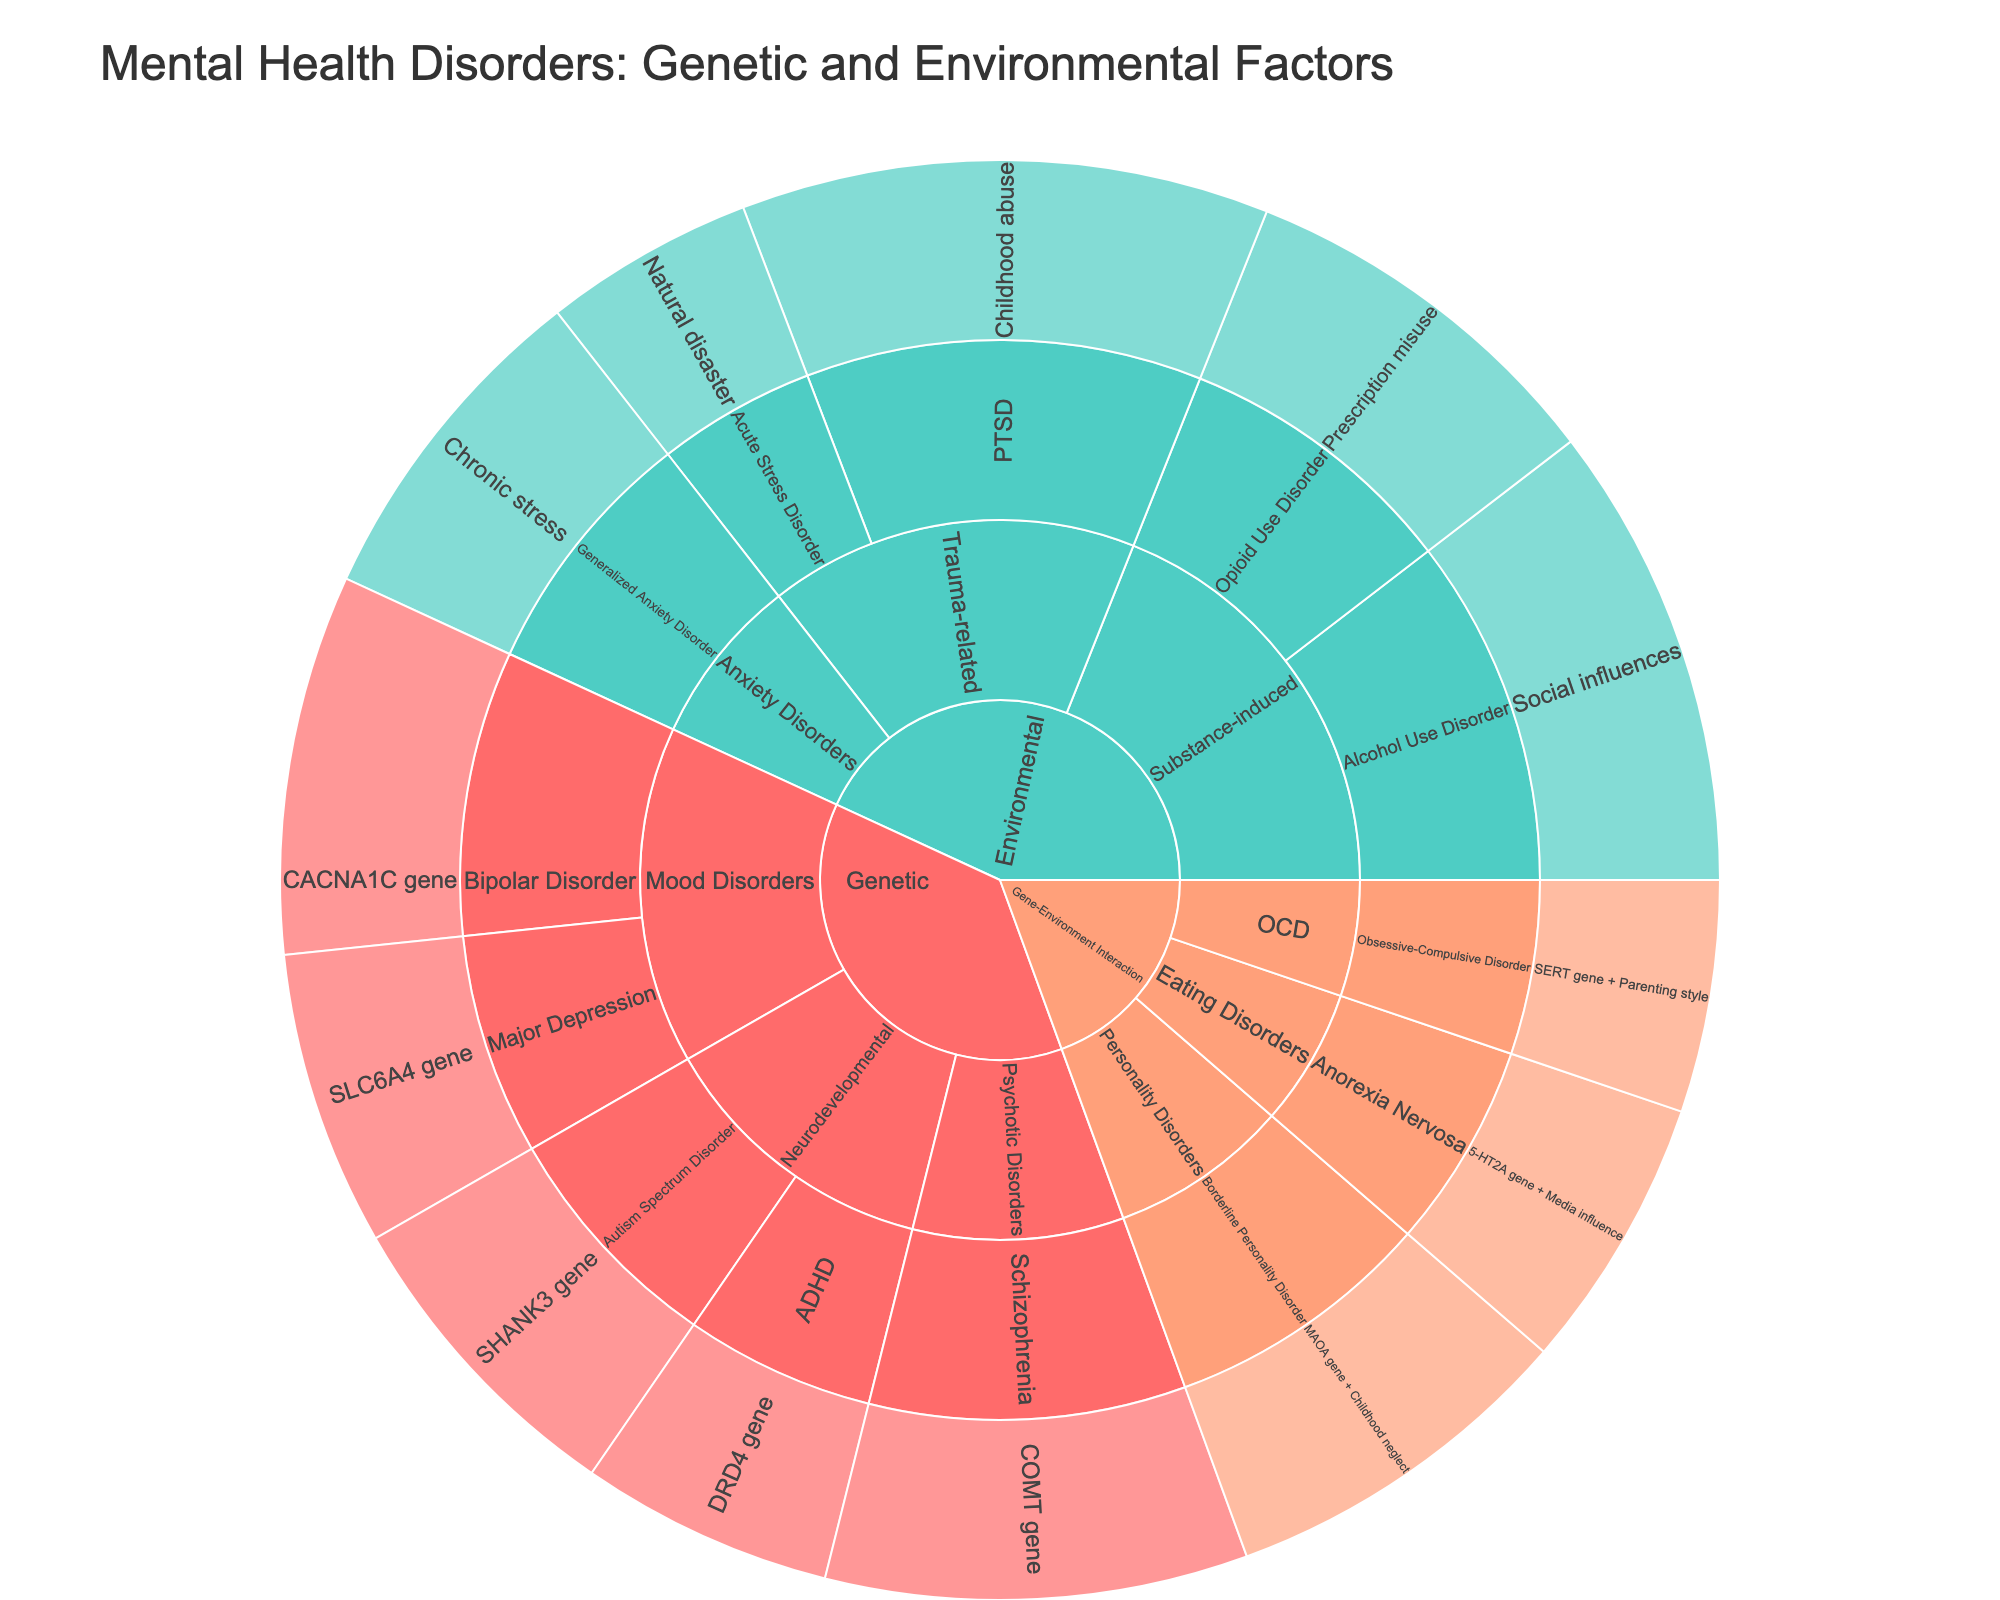What is the title of the Sunburst Plot? The title of the plot is displayed prominently at the top of the figure.
Answer: Mental Health Disorders: Genetic and Environmental Factors Which category has the factor with the highest value? The inner ring represents categories, and we need to look at the factor values in each category and identify the highest value. The "Environmental" category has a factor called "Childhood abuse" related to PTSD, with a value of 25, which is the highest.
Answer: Environmental What factor is associated with Generalized Anxiety Disorder? Trace the path from the "Genetic -> Anxiety Disorders -> Generalized Anxiety Disorder" to find the factor. The factor is listed as "Chronic stress."
Answer: Chronic stress Between Genetic and Environmental categories, which has a higher cumulative value? Calculate the summed values for factors in Genetic (5 disorders: 15 + 12 + 18 + 14 + 20 = 79) and Environmental (5 disorders: 25 + 10 + 22 + 18 + 16 = 91). Environmental has a higher cumulative value.
Answer: Environmental How does the value for Schizophrenia in the Genetic category compare to that for Borderline Personality Disorder in the Gene-Environment Interaction category? Schizophrenia value in Genetic is 20, and Borderline Personality Disorder in Gene-Environment Interaction is 17. Schizophrenia has a higher value.
Answer: Schizophrenia has a higher value What subcategory under the Genetic category has the lowest cumulative value? Calculate the summed values for each subcategory under Genetic: Neurodevelopmental (15 + 12 = 27), Mood Disorders (18 + 14 = 32), Psychotic Disorders (20). Neurodevelopmental has the lowest cumulative value.
Answer: Neurodevelopmental What’s the combined value for all Anxiety Disorders regardless of category? Identify all Anxiety Disorders across categories: Generalized Anxiety Disorder in Environmental has a value of 16. No other Anxiety Disorder is listed. The combined value is 16.
Answer: 16 Which category has the most number of disorders listed? Count the disorders in each category: Genetic (5), Environmental (5), Gene-Environment Interaction (3). Both Genetic and Environmental have the most with 5 disorders each.
Answer: Genetic and Environmental Which factor is linked with the lowest value, and what is that value? The lowest value across all factors is traced to "Obsessive-Compulsive Disorder" related to the factor "SERT gene + Parenting style" with a value of 11 in Gene-Environment Interaction.
Answer: SERT gene + Parenting style, 11 